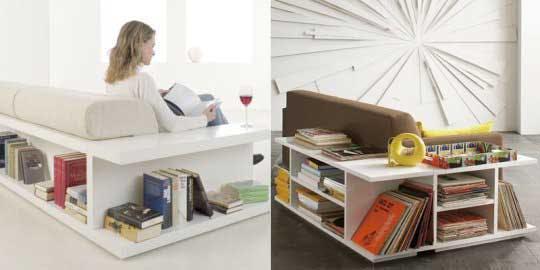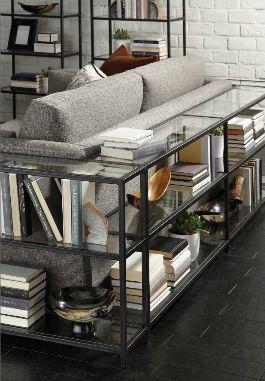The first image is the image on the left, the second image is the image on the right. Analyze the images presented: Is the assertion "The left image shows a woodgrain shelving unit that wraps around the back and side of a couch, with two lamps on its top." valid? Answer yes or no. No. The first image is the image on the left, the second image is the image on the right. Evaluate the accuracy of this statement regarding the images: "In at least one image there is a bookshelf couch with no more than three deep blue pillows.". Is it true? Answer yes or no. No. 